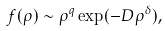Convert formula to latex. <formula><loc_0><loc_0><loc_500><loc_500>f ( \rho ) \sim \rho ^ { q } \exp ( - D \rho ^ { \delta } ) ,</formula> 